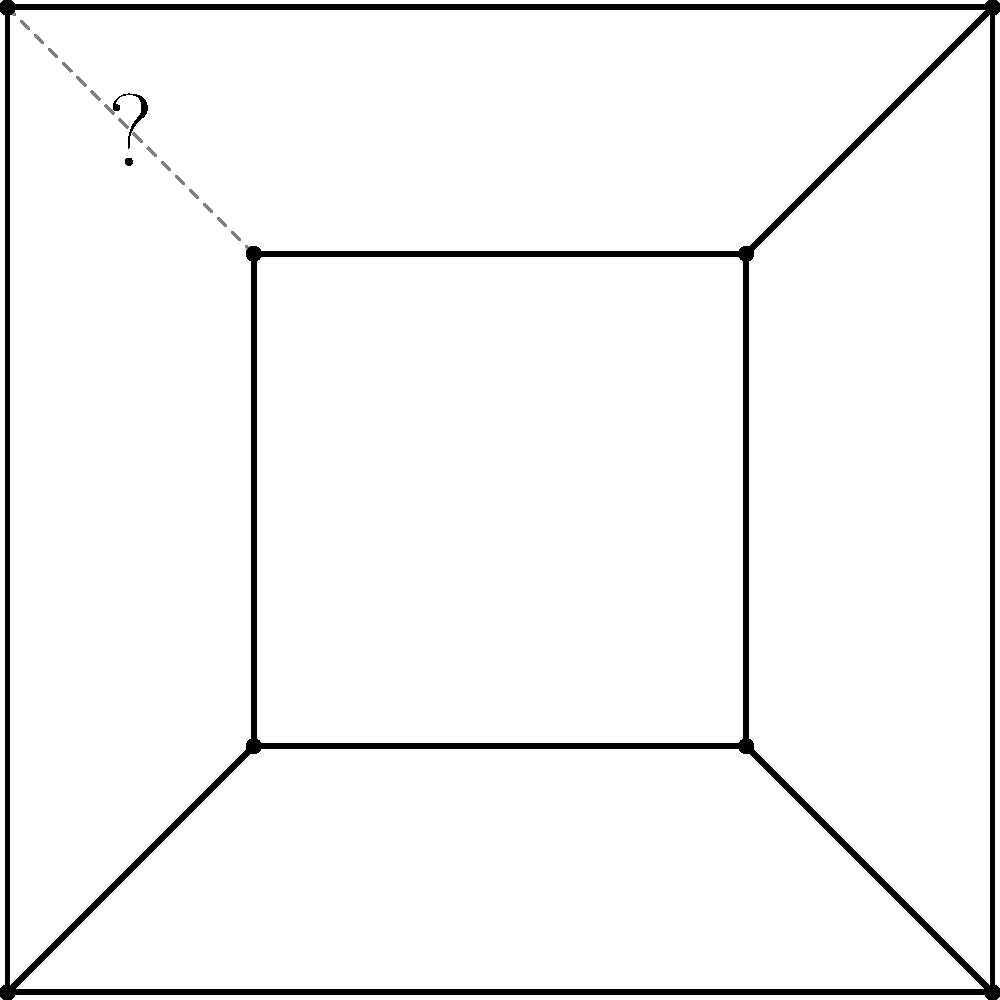In the context of visual information retrieval, consider the partially obscured symmetrical pattern shown above. What is the most likely configuration of the missing line segment indicated by the question mark? To determine the most likely configuration of the missing line segment, we need to analyze the pattern and apply principles of symmetry and visual information retrieval:

1. Observe the overall structure: The diagram shows a square outer frame with a smaller square inside, creating a series of trapezoidal shapes in the corners.

2. Identify the visible elements: Three solid lines connect the corners of the outer square to the corners of the inner square.

3. Recognize the pattern: The visible lines form a consistent pattern, connecting corresponding corners of the two squares.

4. Apply symmetry: Given that the pattern is described as symmetrical, we can infer that the missing segment should complete the pattern in a way that maintains symmetry.

5. Consider visual information retrieval principles: In information retrieval, we often look for completeness and consistency in patterns to extract meaningful data.

6. Deduce the missing segment: The most likely configuration for the missing line segment would be a straight line connecting the top-left corner of the outer square (D) to the top-left corner of the inner square (H).

7. Verify the solution: This completion would maintain the symmetry of the pattern and be consistent with the other visible line segments, making it the most probable configuration in the context of visual information retrieval.
Answer: A straight line from D to H 